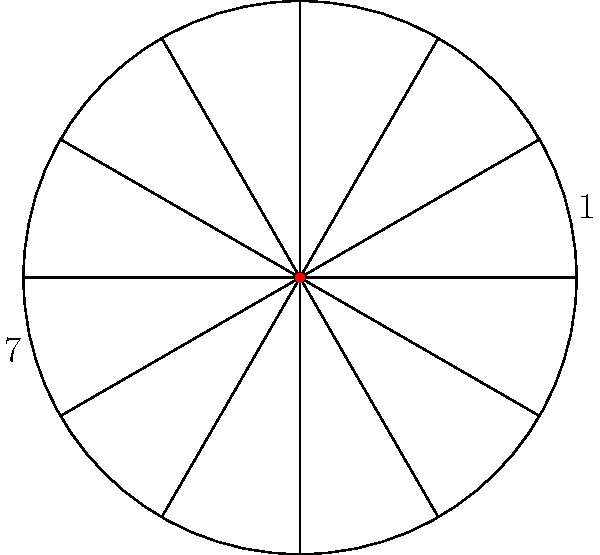In an astrological chart, the 12 houses are typically represented as equal divisions of a circle. If house 1 is rotated 180° around the center of the chart, which house will it overlap with? How does this rotation relate to the concept of opposite houses in astrology? To solve this problem, we need to understand the geometry of the astrological chart and apply the concept of rotational symmetry. Let's break it down step-by-step:

1. The astrological chart is divided into 12 equal sections, each representing a house.
2. Each house occupies a 30° arc of the circle (360° ÷ 12 = 30°).
3. A 180° rotation is equivalent to flipping the position to the exact opposite side of the circle.
4. In the chart, houses directly opposite each other are 6 houses apart (12 ÷ 2 = 6).
5. Starting from house 1 and counting 6 houses clockwise or counterclockwise will bring us to house 7.

Therefore, when house 1 is rotated 180° around the center of the chart, it will overlap with house 7.

This rotation demonstrates the astrological concept of opposite houses. In astrology, opposite houses are considered to have a special relationship, often representing complementary or contrasting themes in a person's life. The 1st and 7th houses, for example, represent the self (1st) and relationships/partnerships (7th), showing how these aspects of life are interconnected and balanced.
Answer: House 7 